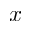Convert formula to latex. <formula><loc_0><loc_0><loc_500><loc_500>x</formula> 